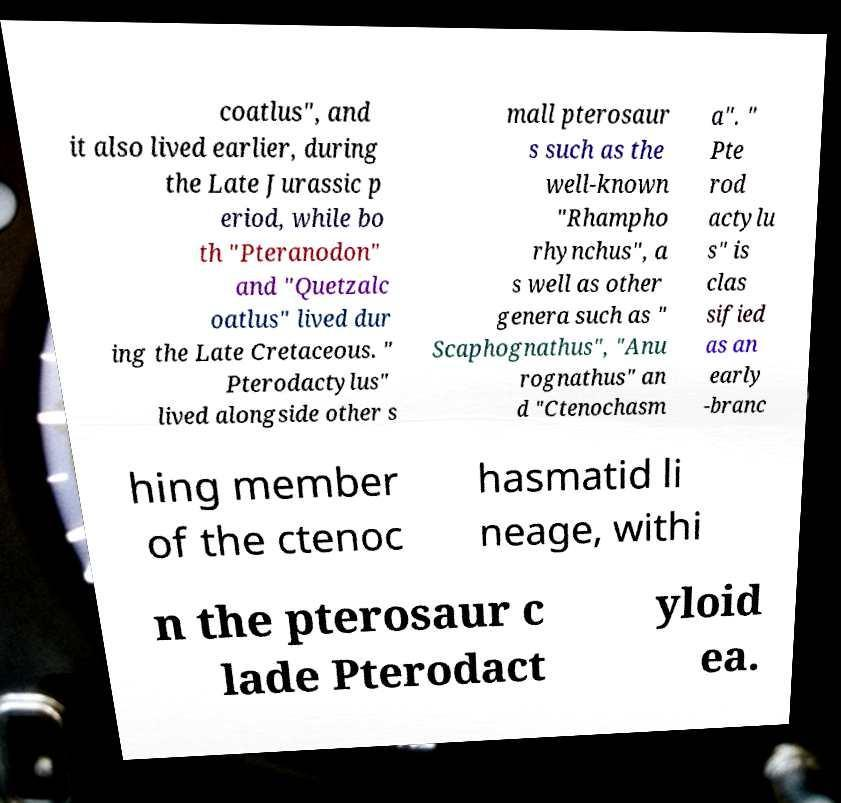Can you accurately transcribe the text from the provided image for me? coatlus", and it also lived earlier, during the Late Jurassic p eriod, while bo th "Pteranodon" and "Quetzalc oatlus" lived dur ing the Late Cretaceous. " Pterodactylus" lived alongside other s mall pterosaur s such as the well-known "Rhampho rhynchus", a s well as other genera such as " Scaphognathus", "Anu rognathus" an d "Ctenochasm a". " Pte rod actylu s" is clas sified as an early -branc hing member of the ctenoc hasmatid li neage, withi n the pterosaur c lade Pterodact yloid ea. 